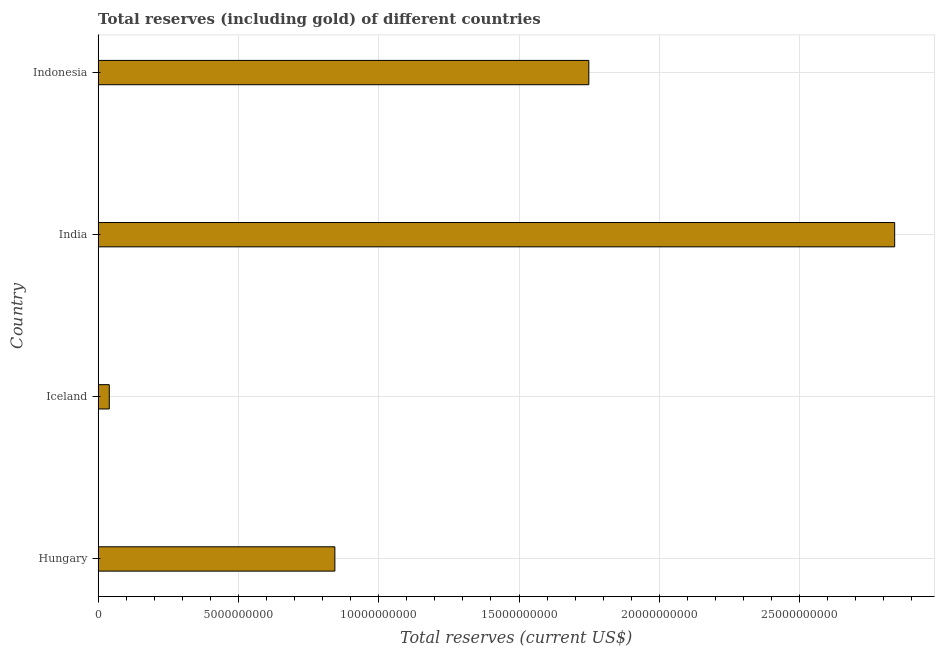Does the graph contain any zero values?
Provide a short and direct response. No. Does the graph contain grids?
Your answer should be very brief. Yes. What is the title of the graph?
Offer a terse response. Total reserves (including gold) of different countries. What is the label or title of the X-axis?
Provide a succinct answer. Total reserves (current US$). What is the total reserves (including gold) in India?
Your response must be concise. 2.84e+1. Across all countries, what is the maximum total reserves (including gold)?
Keep it short and to the point. 2.84e+1. Across all countries, what is the minimum total reserves (including gold)?
Your answer should be compact. 3.98e+08. In which country was the total reserves (including gold) maximum?
Make the answer very short. India. What is the sum of the total reserves (including gold)?
Offer a terse response. 5.47e+1. What is the difference between the total reserves (including gold) in Iceland and India?
Ensure brevity in your answer.  -2.80e+1. What is the average total reserves (including gold) per country?
Your response must be concise. 1.37e+1. What is the median total reserves (including gold)?
Provide a short and direct response. 1.30e+1. What is the ratio of the total reserves (including gold) in Hungary to that in India?
Make the answer very short. 0.3. Is the difference between the total reserves (including gold) in Hungary and India greater than the difference between any two countries?
Offer a very short reply. No. What is the difference between the highest and the second highest total reserves (including gold)?
Offer a terse response. 1.09e+1. What is the difference between the highest and the lowest total reserves (including gold)?
Offer a very short reply. 2.80e+1. In how many countries, is the total reserves (including gold) greater than the average total reserves (including gold) taken over all countries?
Make the answer very short. 2. How many countries are there in the graph?
Your answer should be very brief. 4. What is the difference between two consecutive major ticks on the X-axis?
Your answer should be compact. 5.00e+09. Are the values on the major ticks of X-axis written in scientific E-notation?
Provide a succinct answer. No. What is the Total reserves (current US$) of Hungary?
Your response must be concise. 8.44e+09. What is the Total reserves (current US$) in Iceland?
Offer a terse response. 3.98e+08. What is the Total reserves (current US$) of India?
Give a very brief answer. 2.84e+1. What is the Total reserves (current US$) in Indonesia?
Your response must be concise. 1.75e+1. What is the difference between the Total reserves (current US$) in Hungary and Iceland?
Keep it short and to the point. 8.04e+09. What is the difference between the Total reserves (current US$) in Hungary and India?
Your answer should be very brief. -1.99e+1. What is the difference between the Total reserves (current US$) in Hungary and Indonesia?
Keep it short and to the point. -9.05e+09. What is the difference between the Total reserves (current US$) in Iceland and India?
Provide a succinct answer. -2.80e+1. What is the difference between the Total reserves (current US$) in Iceland and Indonesia?
Offer a very short reply. -1.71e+1. What is the difference between the Total reserves (current US$) in India and Indonesia?
Give a very brief answer. 1.09e+1. What is the ratio of the Total reserves (current US$) in Hungary to that in Iceland?
Your answer should be very brief. 21.2. What is the ratio of the Total reserves (current US$) in Hungary to that in India?
Provide a short and direct response. 0.3. What is the ratio of the Total reserves (current US$) in Hungary to that in Indonesia?
Offer a very short reply. 0.48. What is the ratio of the Total reserves (current US$) in Iceland to that in India?
Offer a very short reply. 0.01. What is the ratio of the Total reserves (current US$) in Iceland to that in Indonesia?
Offer a very short reply. 0.02. What is the ratio of the Total reserves (current US$) in India to that in Indonesia?
Offer a terse response. 1.62. 